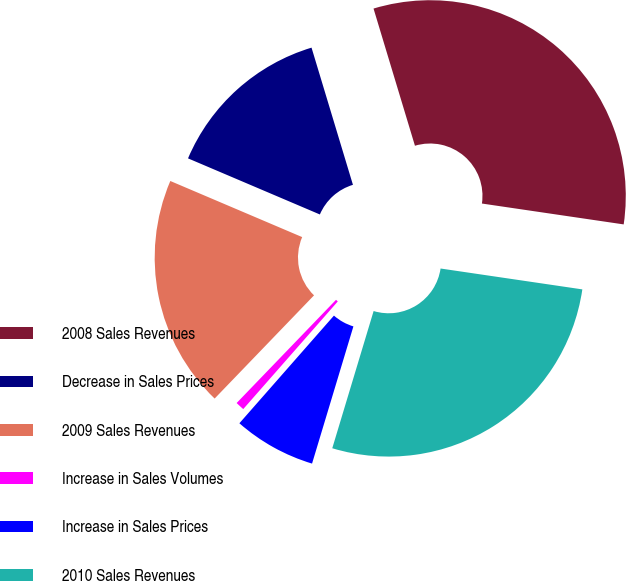Convert chart to OTSL. <chart><loc_0><loc_0><loc_500><loc_500><pie_chart><fcel>2008 Sales Revenues<fcel>Decrease in Sales Prices<fcel>2009 Sales Revenues<fcel>Increase in Sales Volumes<fcel>Increase in Sales Prices<fcel>2010 Sales Revenues<nl><fcel>31.99%<fcel>13.93%<fcel>19.2%<fcel>0.73%<fcel>6.81%<fcel>27.33%<nl></chart> 